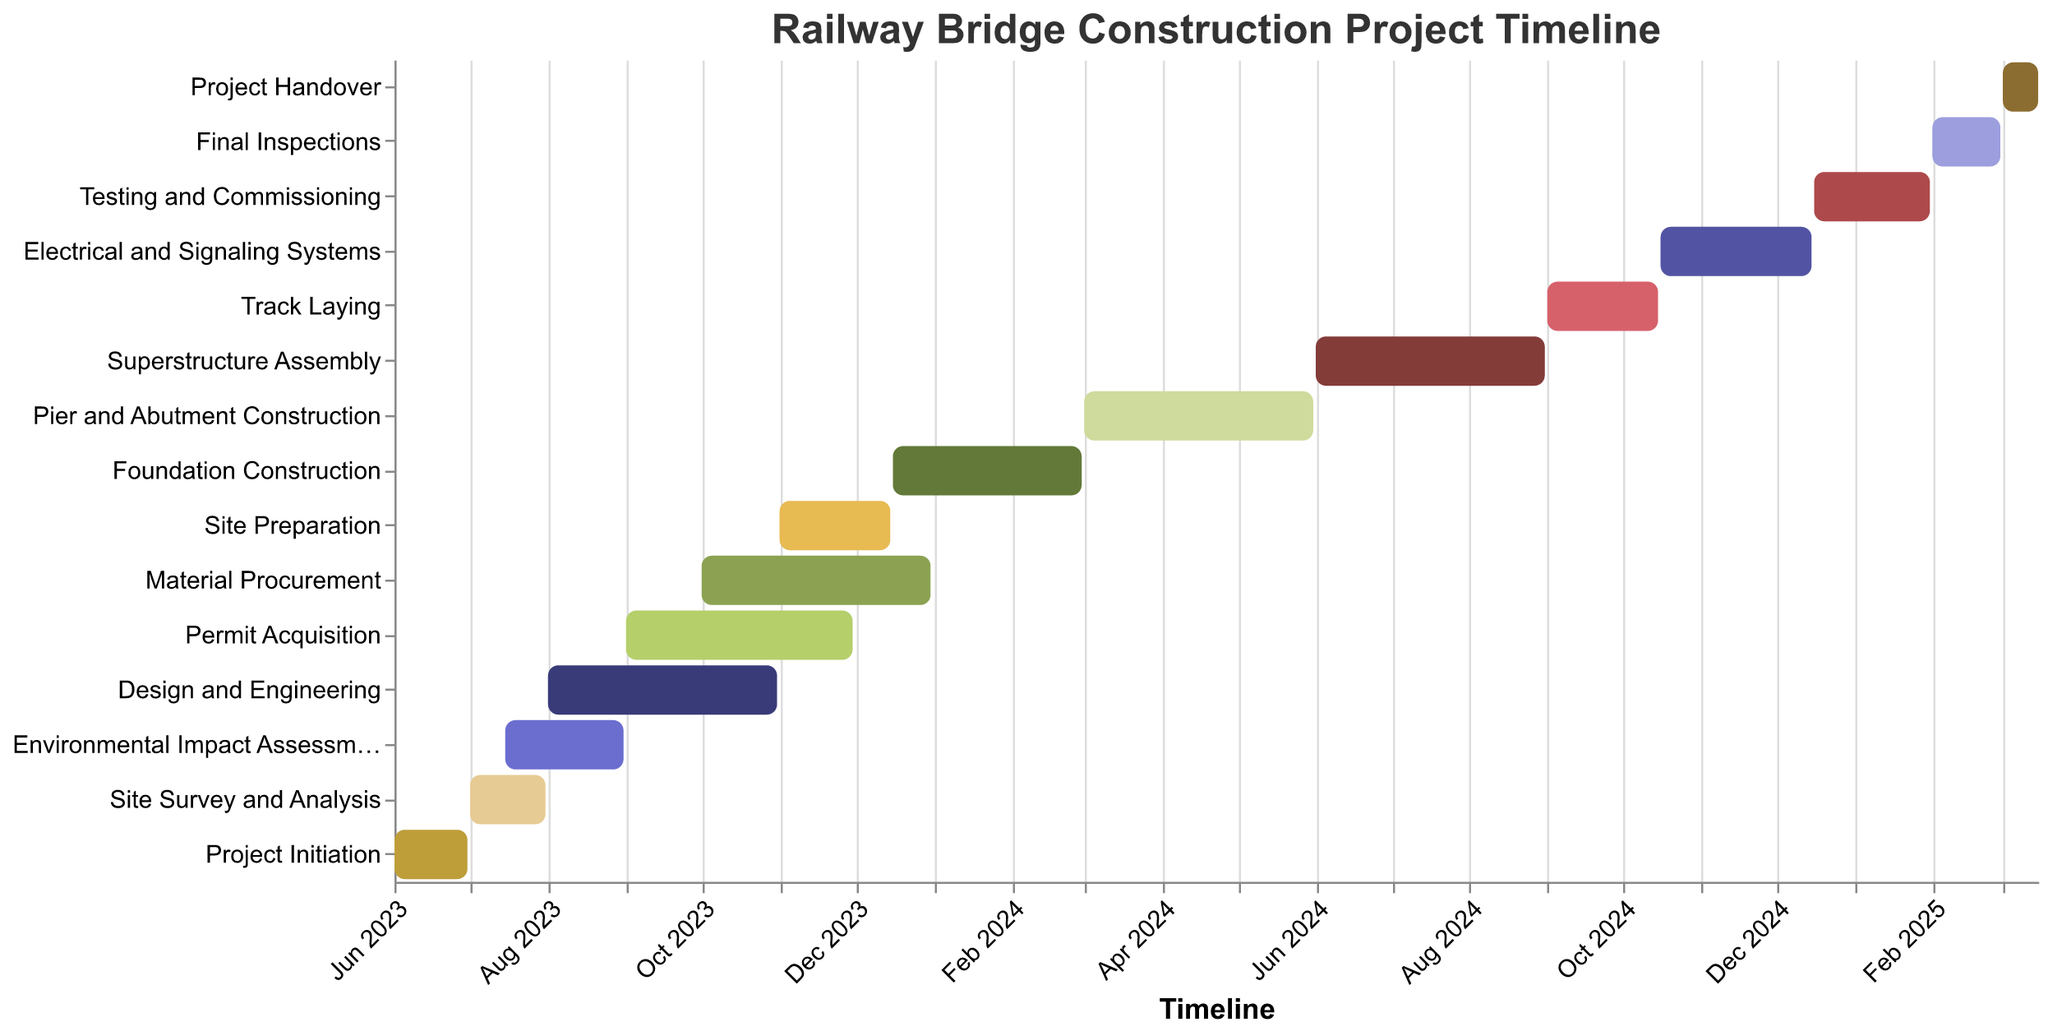What's the title of this chart? The title is usually located at the top of the chart and indicates the main subject of the figure. In this case, the title is "Railway Bridge Construction Project Timeline".
Answer: Railway Bridge Construction Project Timeline What are the start and end dates of the "Superstructure Assembly" phase? To find this, locate the "Superstructure Assembly" task on the y-axis. The corresponding start and end dates will be marked along the x-axis. According to the data, the start date is "2024-06-01" and the end date is "2024-08-31".
Answer: 2024-06-01 to 2024-08-31 Which task has the longest duration? To determine which task has the longest duration, we identify the task with the broadest bar horizontally. The tasks "Design and Engineering", "Material Procurement", "Pier and Abutment Construction", and "Superstructure Assembly" each have the longest duration of 92 days.
Answer: Design and Engineering, Material Procurement, Pier and Abutment Construction, Superstructure Assembly What is the total duration of the "Foundation Construction" phase in days? The duration is directly provided in the figure as a tooltip. For "Foundation Construction", the duration is 76 days.
Answer: 76 days Compare the durations of "Project Initiation" and "Site Survey and Analysis". Which one takes longer, and by how many days? Locate both "Project Initiation" and "Site Survey and Analysis" on the y-axis and compare their respective durations. "Project Initiation" lasts 30 days and "Site Survey and Analysis" lasts 31 days. Therefore, "Site Survey and Analysis" is longer by 1 day.
Answer: Site Survey and Analysis is longer by 1 day When does the task "Permit Acquisition" start and end? Identify the "Permit Acquisition" task on the y-axis of the chart. The x-axis shows the corresponding start and end dates, listed as "2023-09-01" and "2023-11-30", respectively.
Answer: 2023-09-01 to 2023-11-30 What is the duration of the "Testing and Commissioning" phase? The duration is provided in the tooltip when viewing "Testing and Commissioning". According to the data, it lasts for 47 days.
Answer: 47 days Which tasks are scheduled to start in November 2023? Look at the timeline on the x-axis for November 2023 and find which tasks start within this period. "Site Preparation" starts on "2023-11-01".
Answer: Site Preparation When does the overall project begin and end? The overall project begins with the start of the "Project Initiation" phase and ends with the "Project Handover" phase. According to the data, the project begins on "2023-06-01" and ends on "2025-03-15".
Answer: 2023-06-01 to 2025-03-15 What is the total duration of the construction project in days? To find the total duration, calculate the difference between the start and end dates of the project. From "2023-06-01" to "2025-03-15" is 654 days.
Answer: 654 days 